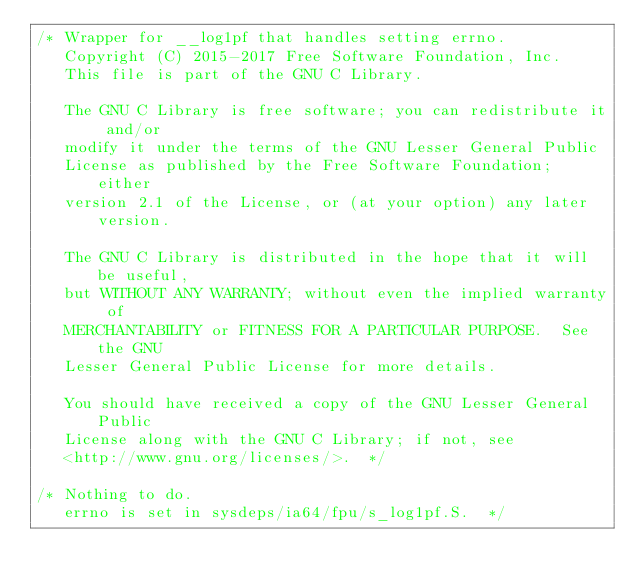Convert code to text. <code><loc_0><loc_0><loc_500><loc_500><_C_>/* Wrapper for __log1pf that handles setting errno.
   Copyright (C) 2015-2017 Free Software Foundation, Inc.
   This file is part of the GNU C Library.

   The GNU C Library is free software; you can redistribute it and/or
   modify it under the terms of the GNU Lesser General Public
   License as published by the Free Software Foundation; either
   version 2.1 of the License, or (at your option) any later version.

   The GNU C Library is distributed in the hope that it will be useful,
   but WITHOUT ANY WARRANTY; without even the implied warranty of
   MERCHANTABILITY or FITNESS FOR A PARTICULAR PURPOSE.  See the GNU
   Lesser General Public License for more details.

   You should have received a copy of the GNU Lesser General Public
   License along with the GNU C Library; if not, see
   <http://www.gnu.org/licenses/>.  */

/* Nothing to do.
   errno is set in sysdeps/ia64/fpu/s_log1pf.S.  */
</code> 